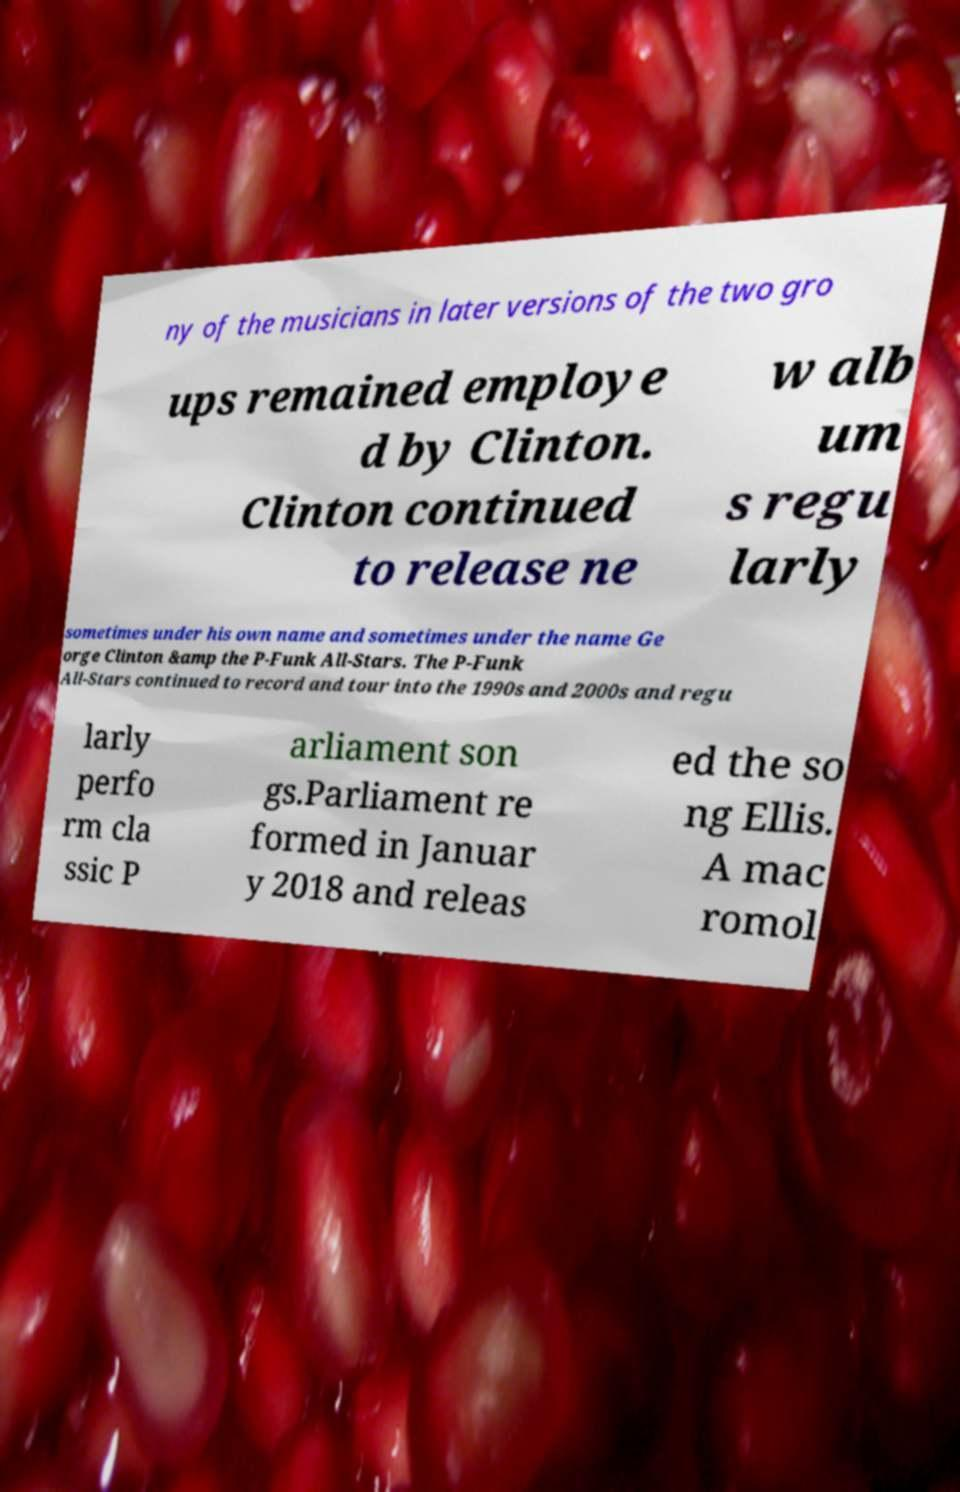Can you read and provide the text displayed in the image?This photo seems to have some interesting text. Can you extract and type it out for me? ny of the musicians in later versions of the two gro ups remained employe d by Clinton. Clinton continued to release ne w alb um s regu larly sometimes under his own name and sometimes under the name Ge orge Clinton &amp the P-Funk All-Stars. The P-Funk All-Stars continued to record and tour into the 1990s and 2000s and regu larly perfo rm cla ssic P arliament son gs.Parliament re formed in Januar y 2018 and releas ed the so ng Ellis. A mac romol 